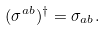<formula> <loc_0><loc_0><loc_500><loc_500>( \sigma ^ { a b } ) ^ { \dagger } = \sigma _ { a b } .</formula> 